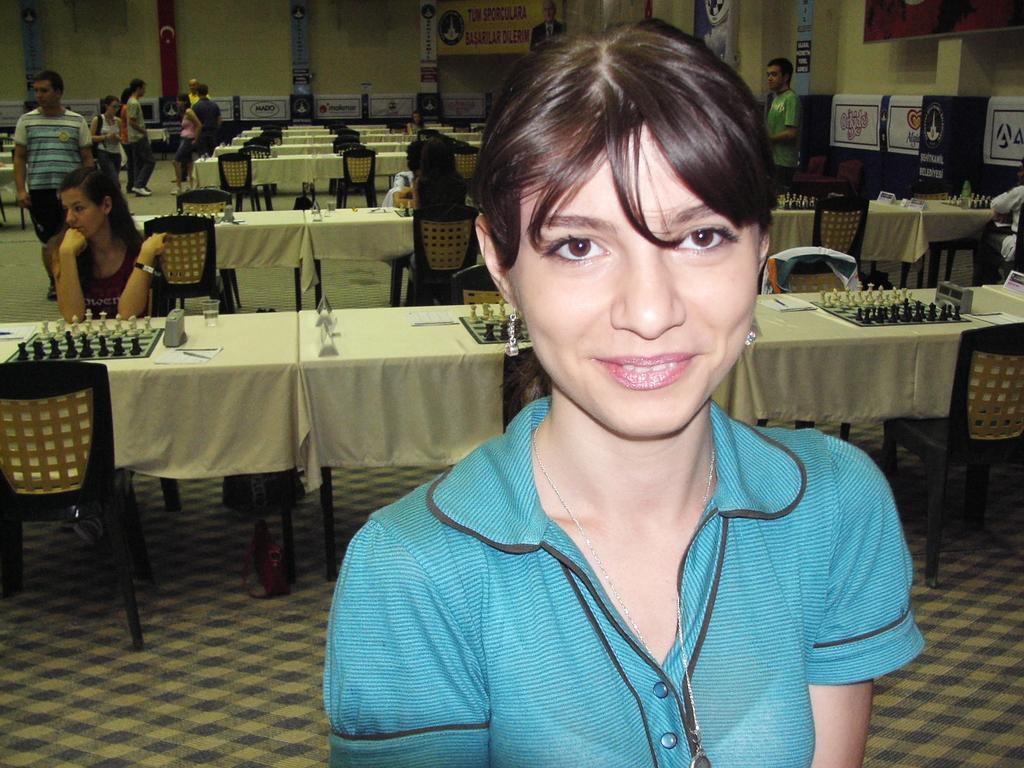Could you give a brief overview of what you see in this image? In this image I can see the person with the blue and black color dress. In the background I can see many people. I can see few people are sitting in-front of the table and few people are standing. I can see the chess boards and pieces on the tables. To the right I can see many banners. In the background I can see few more banners and the wall. 